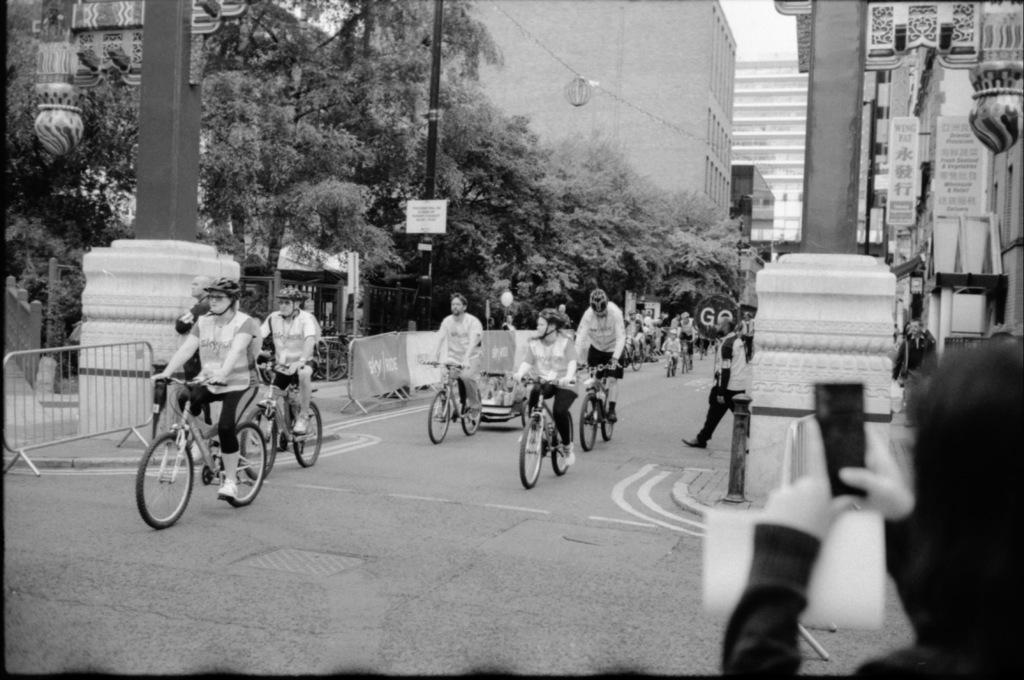What are the people in the image doing? The persons in the image are on bicycles. What is the setting of the image? The image depicts a road. What structure can be seen in the image? There is a building visible in the image. What type of vegetation is present in the image? Trees are present in the image. What other object can be seen in the image? There is a pole in the image. What statement is being made by the advertisement on the side of the road in the image? There is no advertisement present in the image; it only shows persons on bicycles, a road, a building, trees, and a pole. 